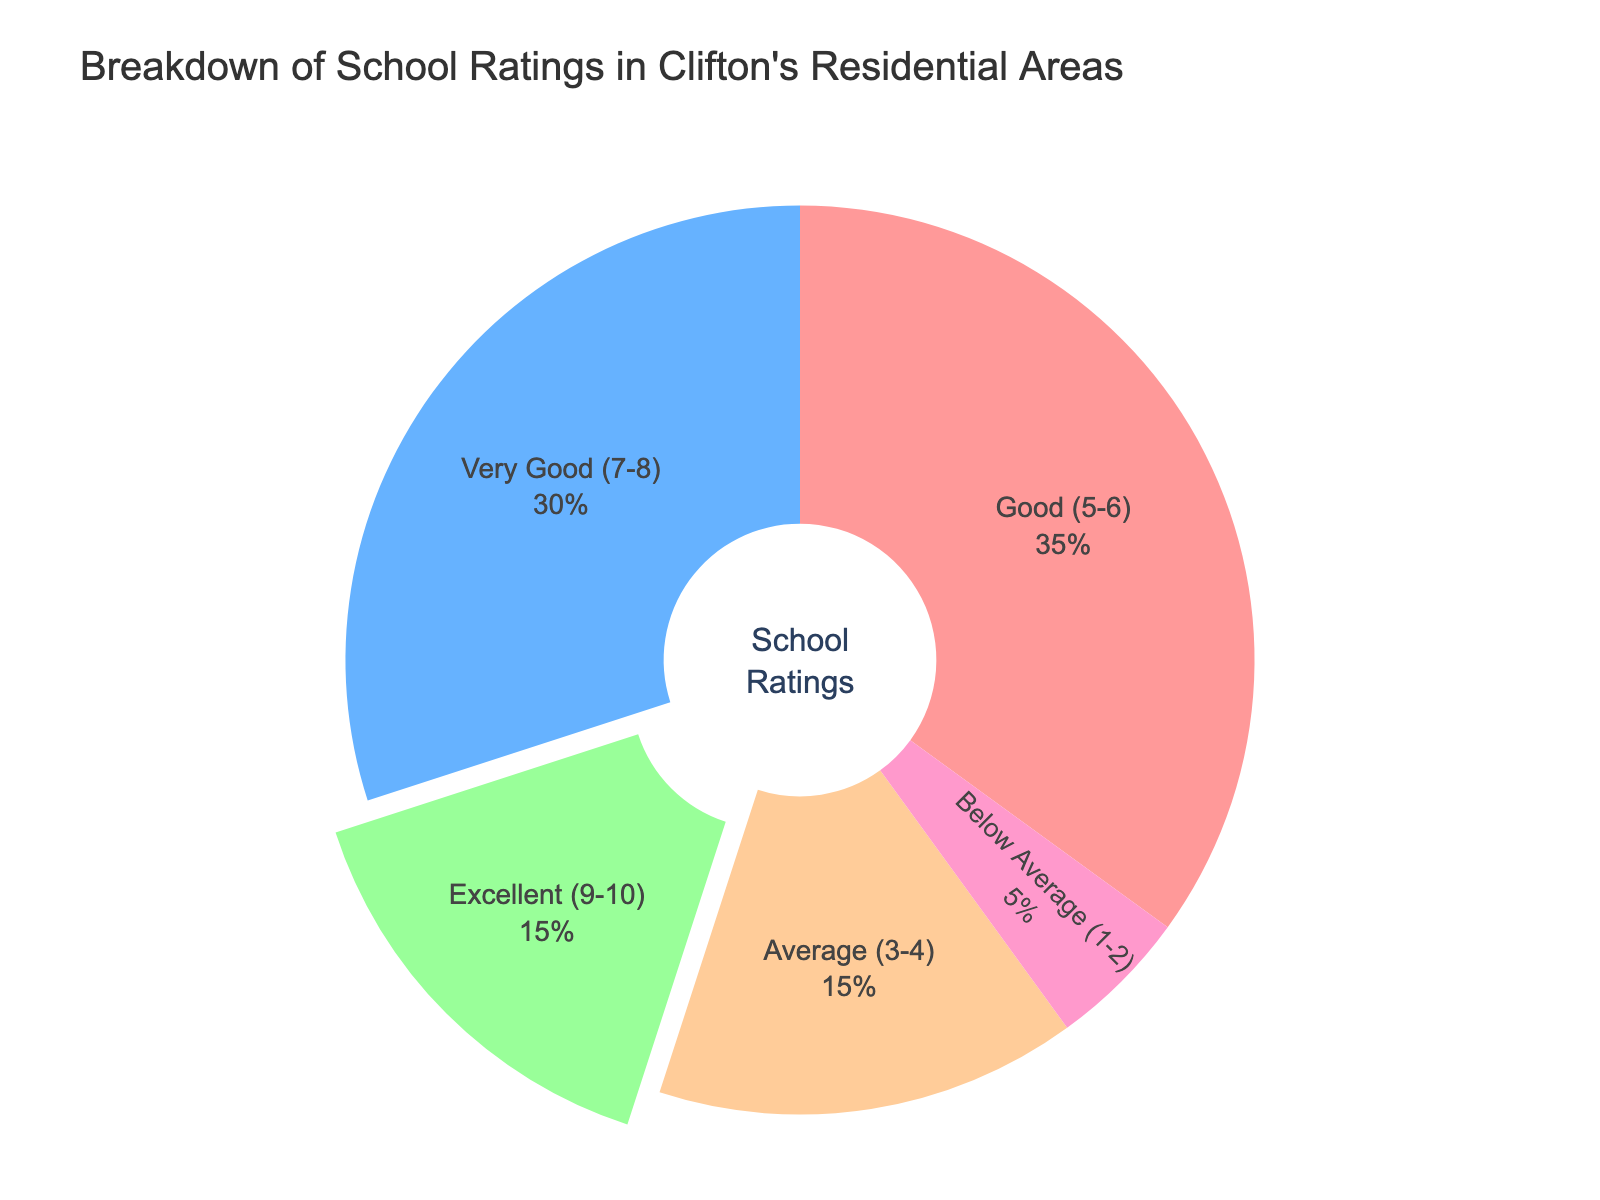What percentage of schools are rated as Excellent? The pie chart shows the breakdown of school ratings by percentage. The segment labeled "Excellent (9-10)" represents 15% of the schools.
Answer: 15% Which school rating category has the highest percentage? By examining the pie chart, the "Good (5-6)" segment is the largest, indicating it has the highest percentage at 35%.
Answer: Good (5-6) What is the difference in percentage between schools rated as Very Good and those rated as Below Average? The percentage for Very Good (7-8) is 30%, and Below Average (1-2) is 5%. Subtract 5 from 30 to find the difference. 30% - 5% = 25%.
Answer: 25% How many categories have a percentage of schools rated at or above 15%? The categories with percentages at or above 15% are Excellent (15%), Very Good (30%), Good (35%), and Average (15%). Count these categories to get the total.
Answer: 4 Are there more schools rated as Average or as Below Average? The chart shows the percentage of schools rated as Average (3-4) is 15%, while Below Average (1-2) is 5%. Comparing these values shows there are more schools rated as Average.
Answer: Average (3-4) What is the combined percentage of schools rated as Excellent and Average? The chart indicates 15% for Excellent (9-10) and 15% for Average (3-4). Adding these percentages gives 15% + 15% = 30%.
Answer: 30% Which two school rating categories together make up exactly half the overall percentage? The categories Good (5-6) and Very Good (7-8) have 35% and 30%, respectively. Together, they sum to 35% + 30% = 65%, which is more than half. However, Excellent (9-10) and Average (3-4) add up to 15% + 15% = 30%, which is incorrect. Only one category, Good (5-6), has a direct sum when doubled equal to half (50% of 100%).
Answer: Good (5-6) does not combine exactly with any one other category to make half, but alone it holds 35% which is significant compared to other pairs What is the average percentage of schools rated Excellent, Very Good, and Good? The percentages are 15% (Excellent), 30% (Very Good), and 35% (Good). To find the average, sum these percentages and divide by the number of categories: (15% + 30% + 35%) / 3 = 80% / 3 ≈ 26.67%.
Answer: 26.67% How much larger is the percentage of schools rated Good compared to those rated as Excellent? The percentage for Good (5-6) is 35% and for Excellent (9-10) is 15%. Subtracting the percentage of Excellent from Good, we get 35% - 15% = 20%.
Answer: 20% What color represents schools rated as Below Average? Observing the pie chart, the segment for Below Average (1-2) is colored in a distinct shade. It is represented by a pink color.
Answer: Pink 